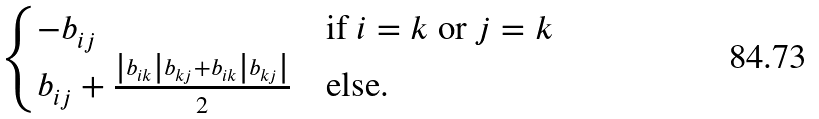Convert formula to latex. <formula><loc_0><loc_0><loc_500><loc_500>\begin{cases} - b _ { i j } & \text {if $i=k$ or $j=k$} \\ b _ { i j } + \frac { \left | b _ { i k } \right | b _ { k j } + b _ { i k } \left | b _ { k j } \right | } { 2 } & \text {else.} \end{cases}</formula> 